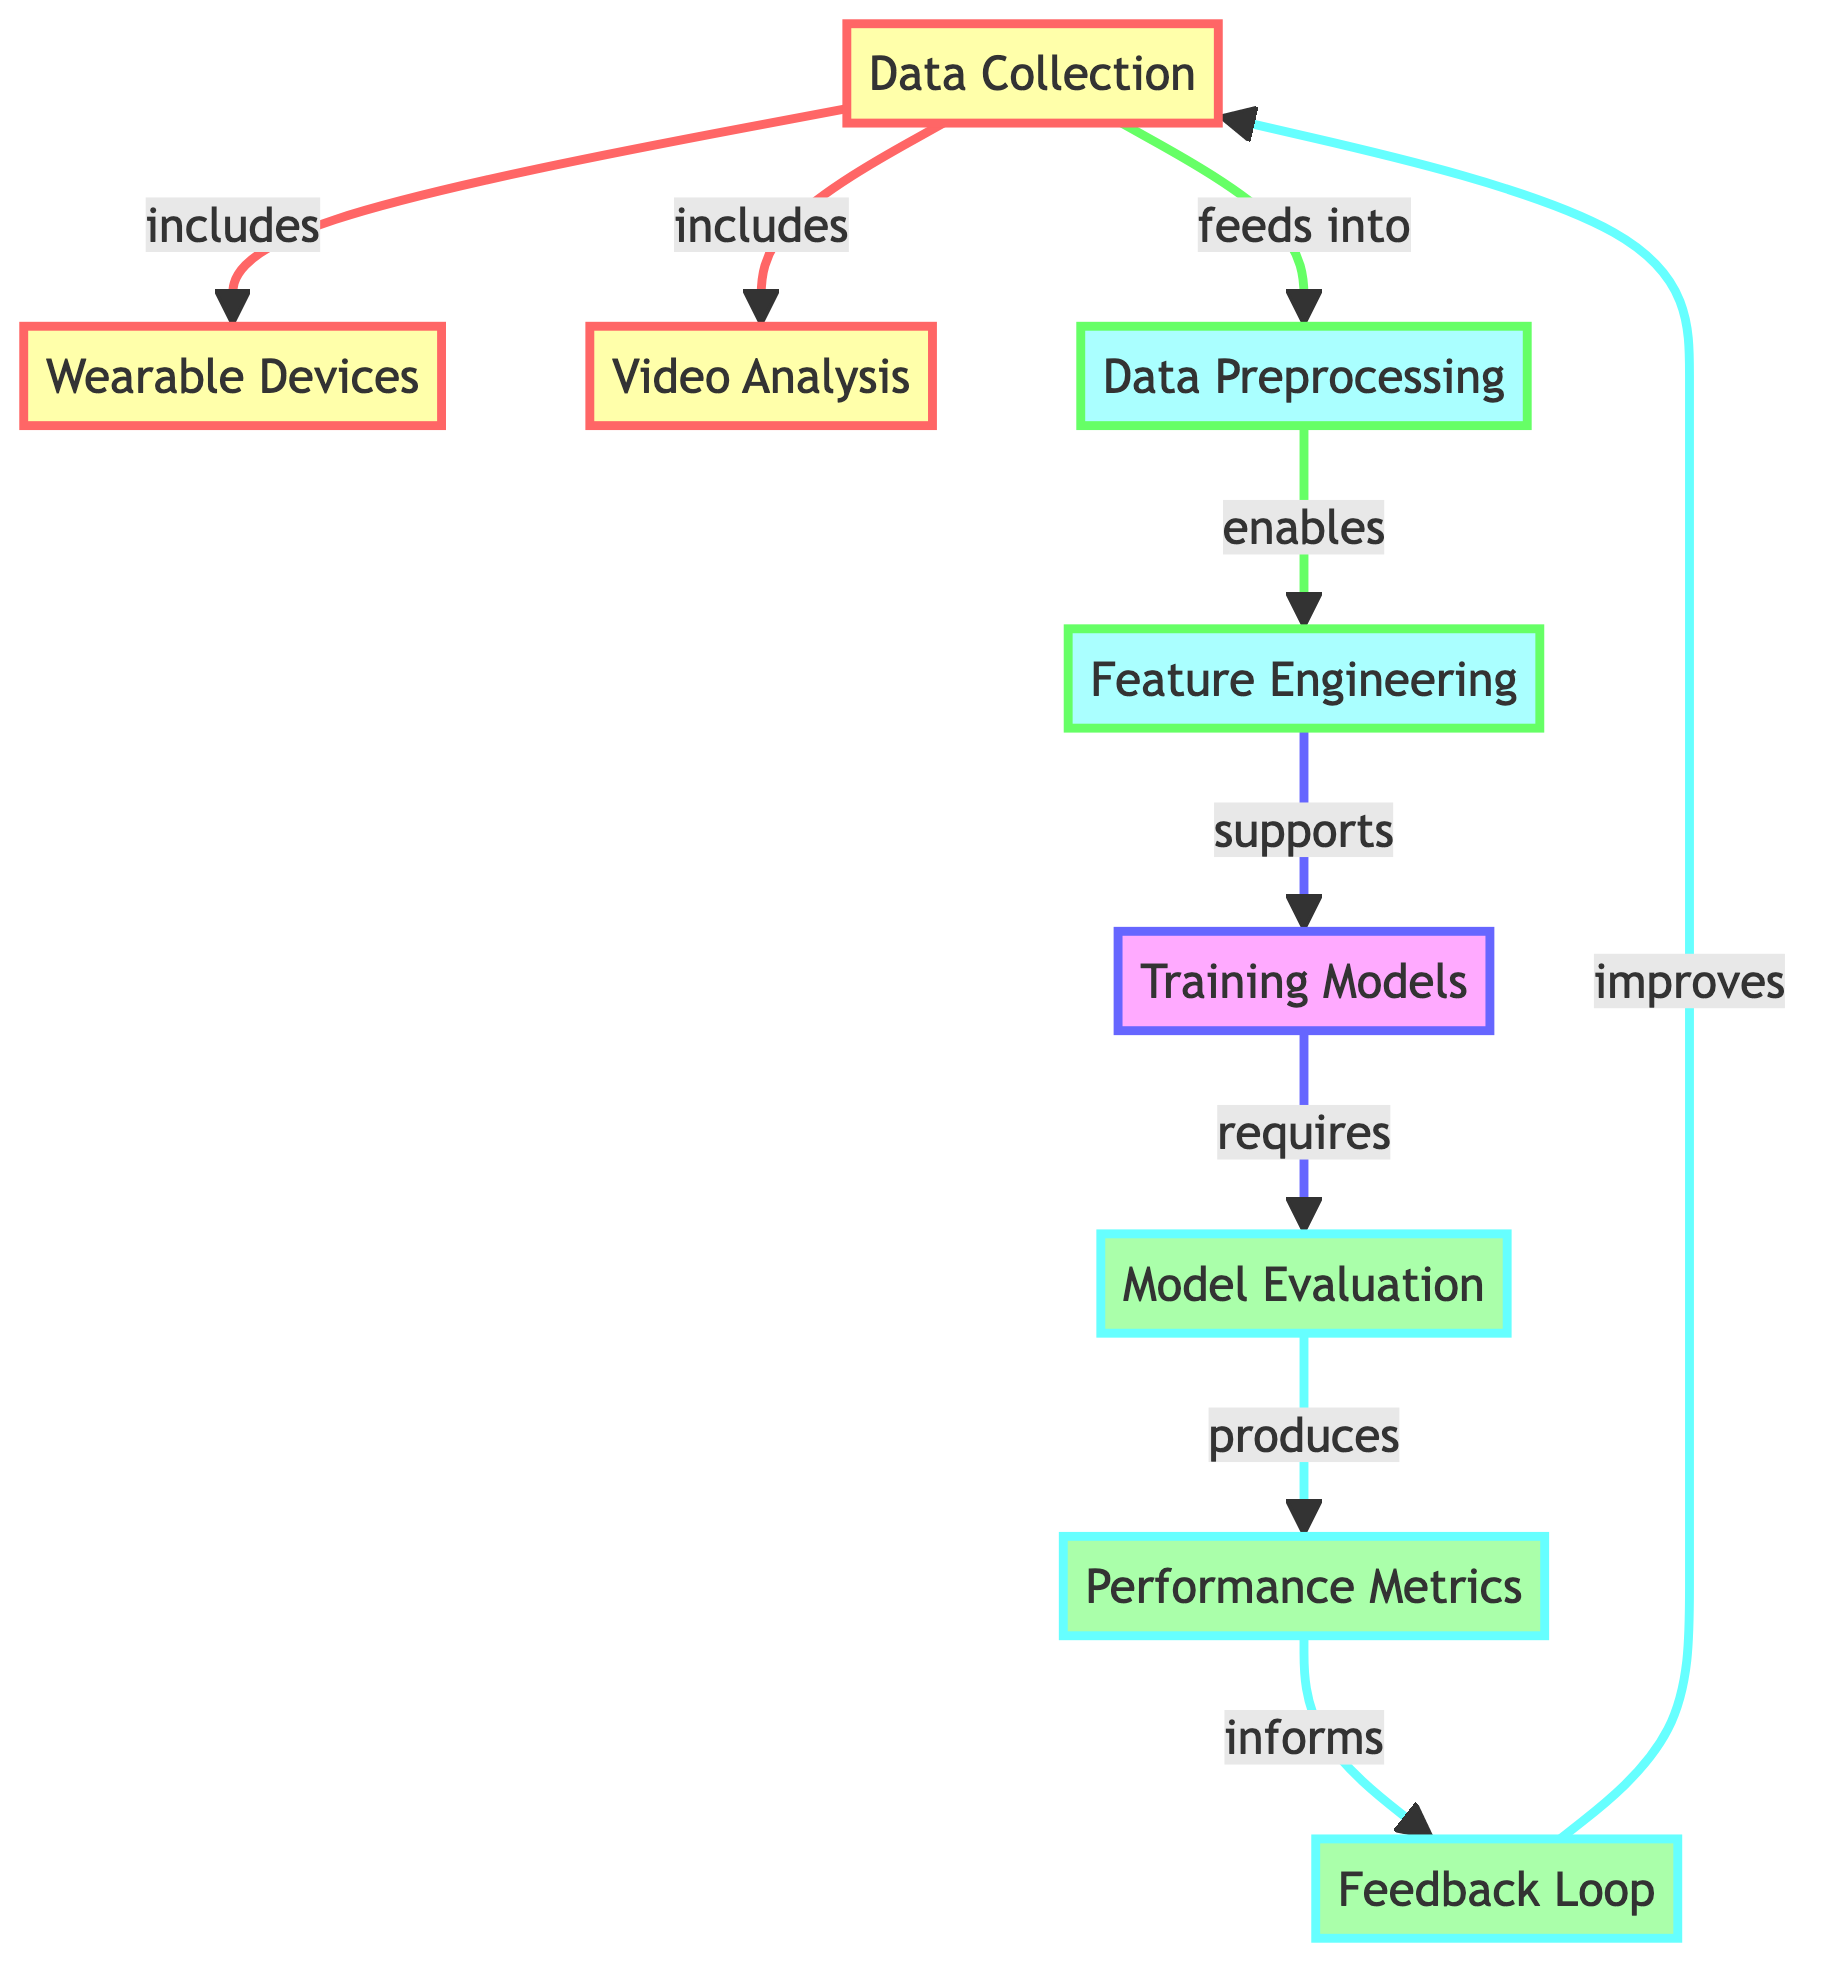What are the two main components of data collection? The diagram indicates that data collection includes wearable devices and video analysis as its components. This can be directly observed from the arrows leading from the data collection node to both wearable devices and video analysis.
Answer: wearable devices, video analysis Which process directly follows data preprocessing? Based on the flow of the diagram, the process that directly follows data preprocessing is feature engineering. This can be seen from the arrow connecting the data preprocessing node to the feature engineering node.
Answer: feature engineering How many processes are represented in the diagram? The diagram contains six distinct processes: data collection, data preprocessing, feature engineering, training models, model evaluation, and feedback loop. One can count the nodes in the middle sections connected by arrows to determine this total.
Answer: six What does the feedback loop improve? The feedback loop is shown to improve data collection, as indicated by the arrow that points from the feedback loop back to the data collection node.
Answer: data collection What is the output of the model evaluation process? The output produced by the model evaluation process is performance metrics. This is evidenced by the arrow leading away from the model evaluation node connecting to performance metrics.
Answer: performance metrics What supports training models in the diagram? The feature engineering process supports training models according to the diagram. This relationship is highlighted by the arrow connecting feature engineering to training models.
Answer: feature engineering What relationship does video analysis have with data collection? Video analysis is a component of data collection, as shown by the connection leading from the data collection node to the video analysis node. This illustrates that video analysis is included within the data collection process.
Answer: included Which flowchart category does the 'training models' node fall under? The 'training models' node is in the modeling category, as indicated by the specific color coding in the diagram associated with that classification. The diagram shows this with a distinct styling for modeling processes.
Answer: modeling 